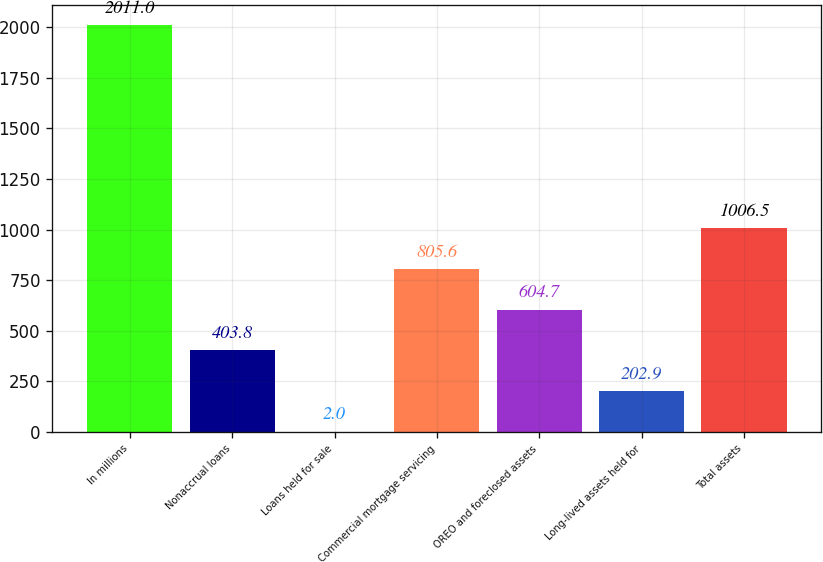Convert chart to OTSL. <chart><loc_0><loc_0><loc_500><loc_500><bar_chart><fcel>In millions<fcel>Nonaccrual loans<fcel>Loans held for sale<fcel>Commercial mortgage servicing<fcel>OREO and foreclosed assets<fcel>Long-lived assets held for<fcel>Total assets<nl><fcel>2011<fcel>403.8<fcel>2<fcel>805.6<fcel>604.7<fcel>202.9<fcel>1006.5<nl></chart> 